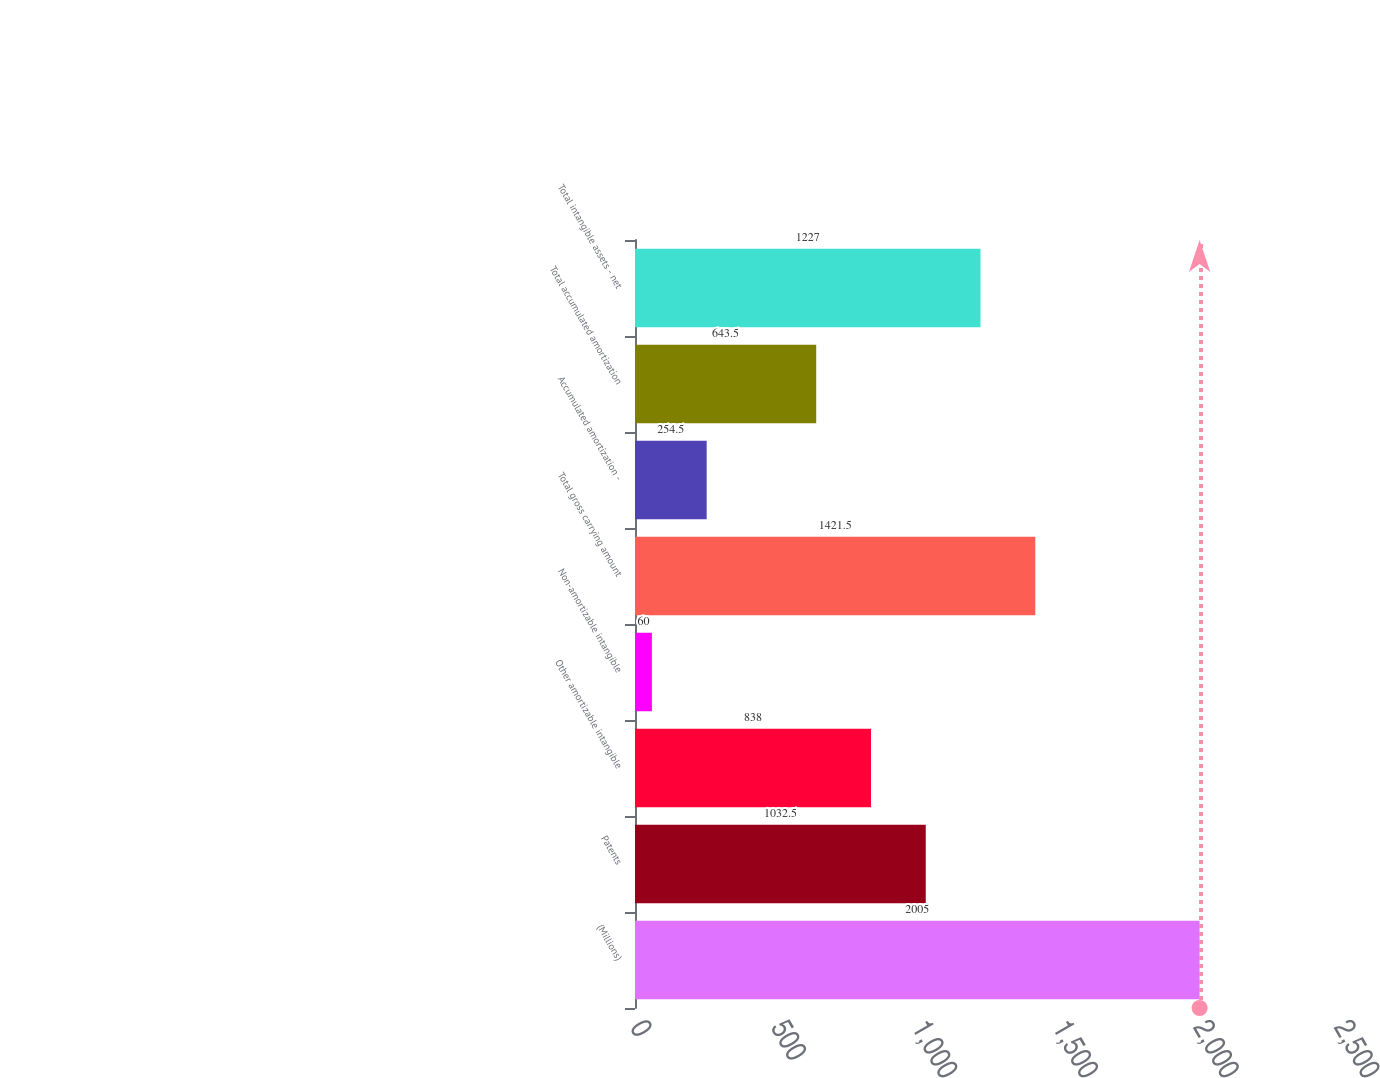Convert chart to OTSL. <chart><loc_0><loc_0><loc_500><loc_500><bar_chart><fcel>(Millions)<fcel>Patents<fcel>Other amortizable intangible<fcel>Non-amortizable intangible<fcel>Total gross carrying amount<fcel>Accumulated amortization -<fcel>Total accumulated amortization<fcel>Total intangible assets - net<nl><fcel>2005<fcel>1032.5<fcel>838<fcel>60<fcel>1421.5<fcel>254.5<fcel>643.5<fcel>1227<nl></chart> 